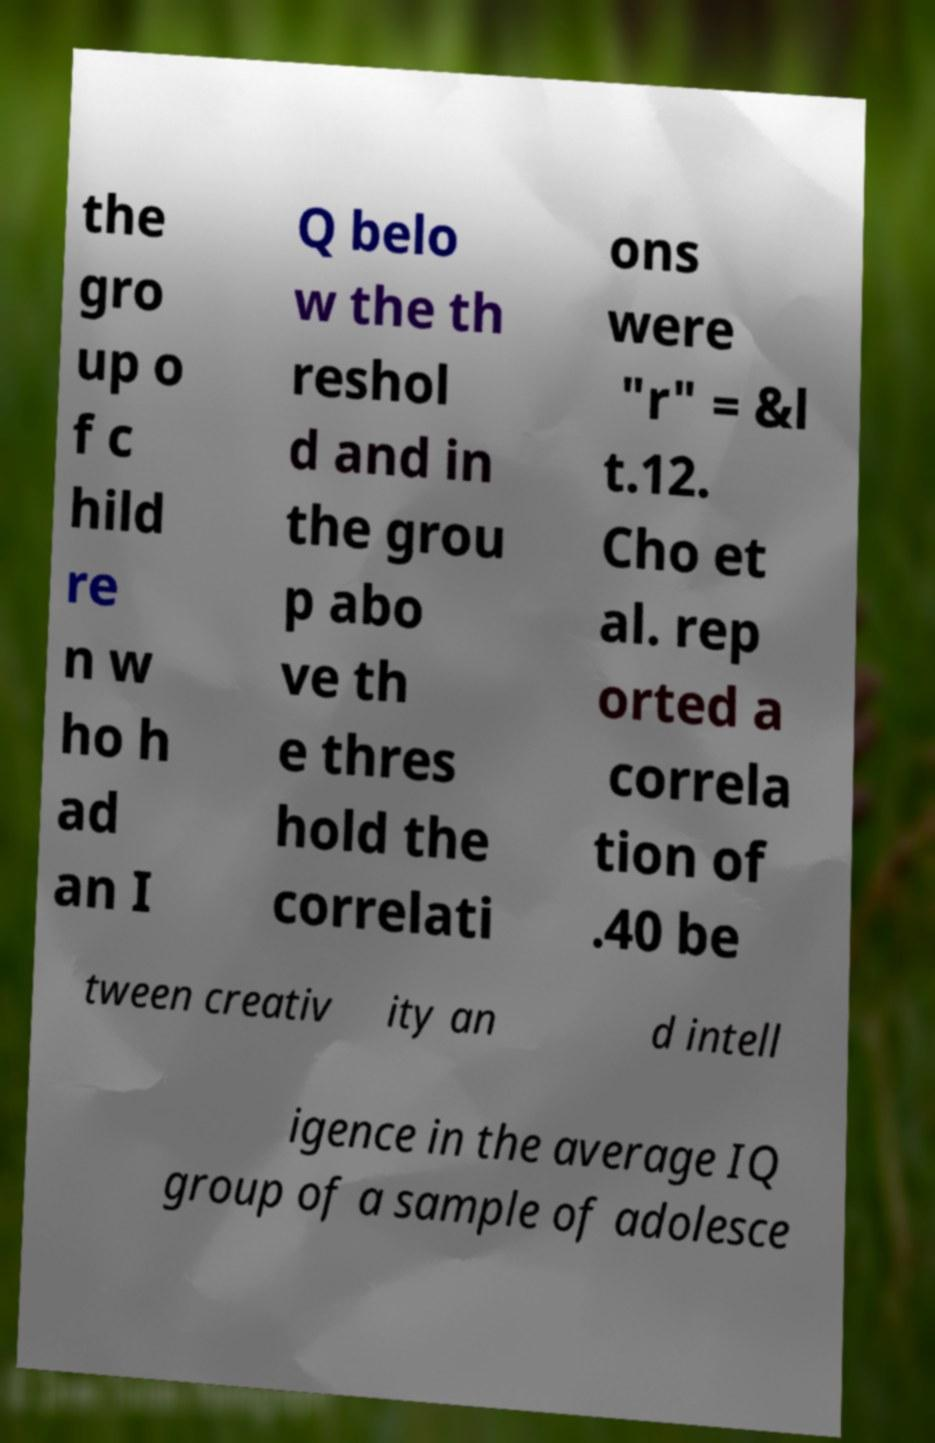Can you accurately transcribe the text from the provided image for me? the gro up o f c hild re n w ho h ad an I Q belo w the th reshol d and in the grou p abo ve th e thres hold the correlati ons were "r" = &l t.12. Cho et al. rep orted a correla tion of .40 be tween creativ ity an d intell igence in the average IQ group of a sample of adolesce 